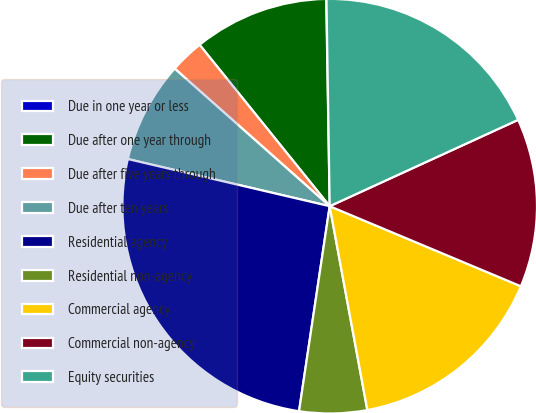<chart> <loc_0><loc_0><loc_500><loc_500><pie_chart><fcel>Due in one year or less<fcel>Due after one year through<fcel>Due after five years through<fcel>Due after ten years<fcel>Residential agency<fcel>Residential non-agency<fcel>Commercial agency<fcel>Commercial non-agency<fcel>Equity securities<nl><fcel>0.02%<fcel>10.53%<fcel>2.65%<fcel>7.9%<fcel>26.29%<fcel>5.27%<fcel>15.78%<fcel>13.15%<fcel>18.41%<nl></chart> 